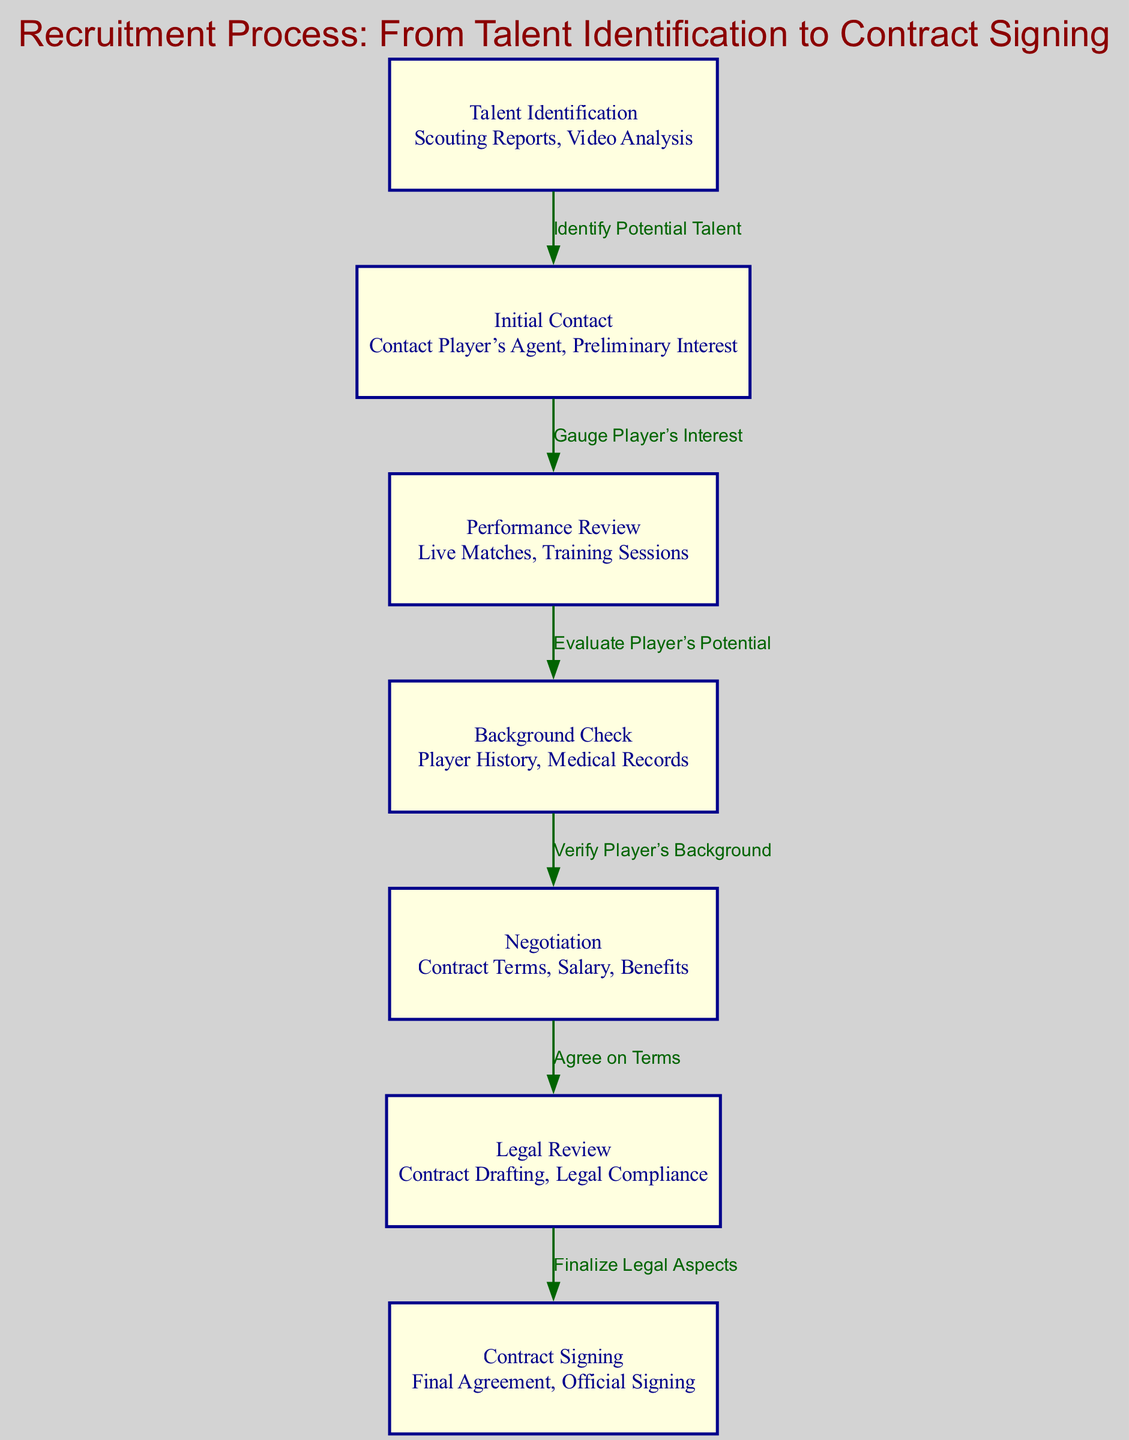What is the first step in the recruitment process? The diagram indicates that the first step is "Talent Identification," which includes scouting reports and video analysis.
Answer: Talent Identification How many nodes are in the diagram? By counting the nodes listed in the diagram, there are a total of seven distinct nodes.
Answer: 7 Which step follows "Performance Review"? According to the flowchart, "Background Check" follows "Performance Review" as the next step in the recruitment process.
Answer: Background Check What is the relationship between "Negotiation" and "Legal Review"? The flowchart shows that "Negotiation" leads directly to "Legal Review," indicating that after agreeing on terms, legal aspects are finalized.
Answer: Agree on Terms What is included in the "Background Check"? In the diagram, the "Background Check" consists of verifying the player's history and medical records.
Answer: Player History, Medical Records Which node leads to "Contract Signing"? The node that leads directly to "Contract Signing" is "Legal Review," as this step finalizes the legal aspects before the contract signing.
Answer: Legal Review What are the descriptions of "Initial Contact"? The "Initial Contact" node includes the actions of contacting the player’s agent and gauging preliminary interest.
Answer: Contact Player’s Agent, Preliminary Interest How many edges are connecting the nodes in the diagram? By examining the flowchart, there are a total of six edges connecting the seven nodes in the recruitment process.
Answer: 6 What does the node "Performance Review" evaluate? The "Performance Review" is focused on evaluating live matches and training sessions to assess a player's potential.
Answer: Live Matches, Training Sessions Which final step is represented in the recruitment process? The last step in the recruitment process is "Contract Signing," indicating that this is where the final agreement is made officially.
Answer: Contract Signing 